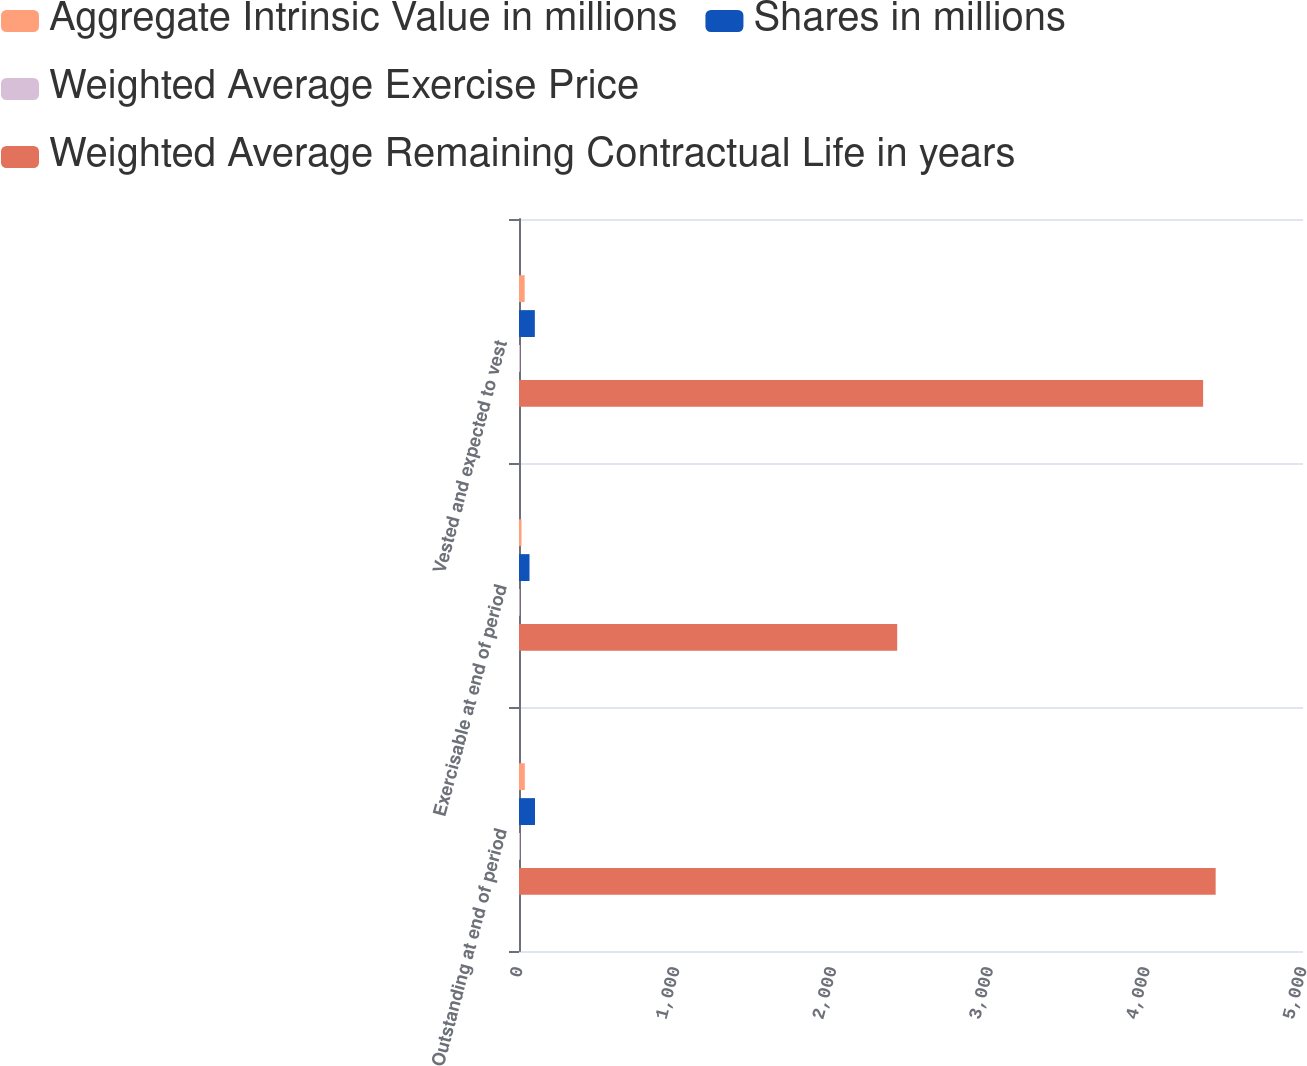<chart> <loc_0><loc_0><loc_500><loc_500><stacked_bar_chart><ecel><fcel>Outstanding at end of period<fcel>Exercisable at end of period<fcel>Vested and expected to vest<nl><fcel>Aggregate Intrinsic Value in millions<fcel>37<fcel>16<fcel>36<nl><fcel>Shares in millions<fcel>102<fcel>67<fcel>101<nl><fcel>Weighted Average Exercise Price<fcel>6.6<fcel>4.8<fcel>6.6<nl><fcel>Weighted Average Remaining Contractual Life in years<fcel>4443<fcel>2412<fcel>4363<nl></chart> 